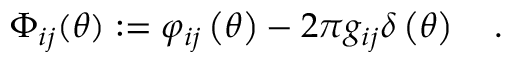<formula> <loc_0><loc_0><loc_500><loc_500>\Phi _ { i j } ( \theta ) \colon = \varphi _ { i j } \left ( \theta \right ) - 2 \pi g _ { i j } \delta \left ( \theta \right ) \quad .</formula> 